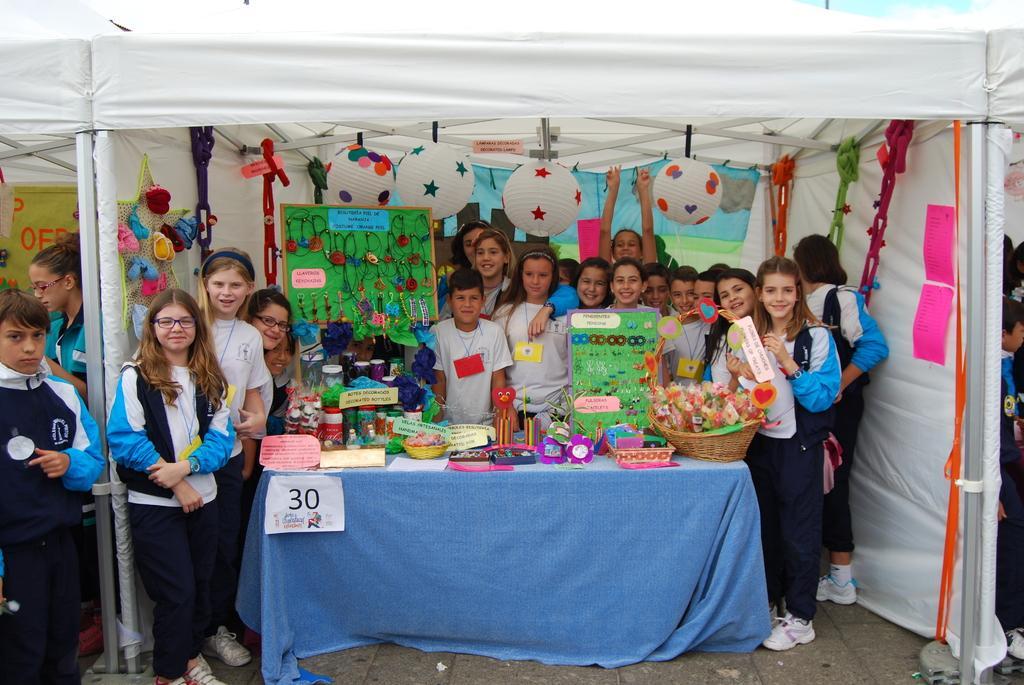How would you summarize this image in a sentence or two? In this picture there are group of people who are standing. There is a basket, toy,earrings and few objects on the table. There is a boar's, cloth and paper. 